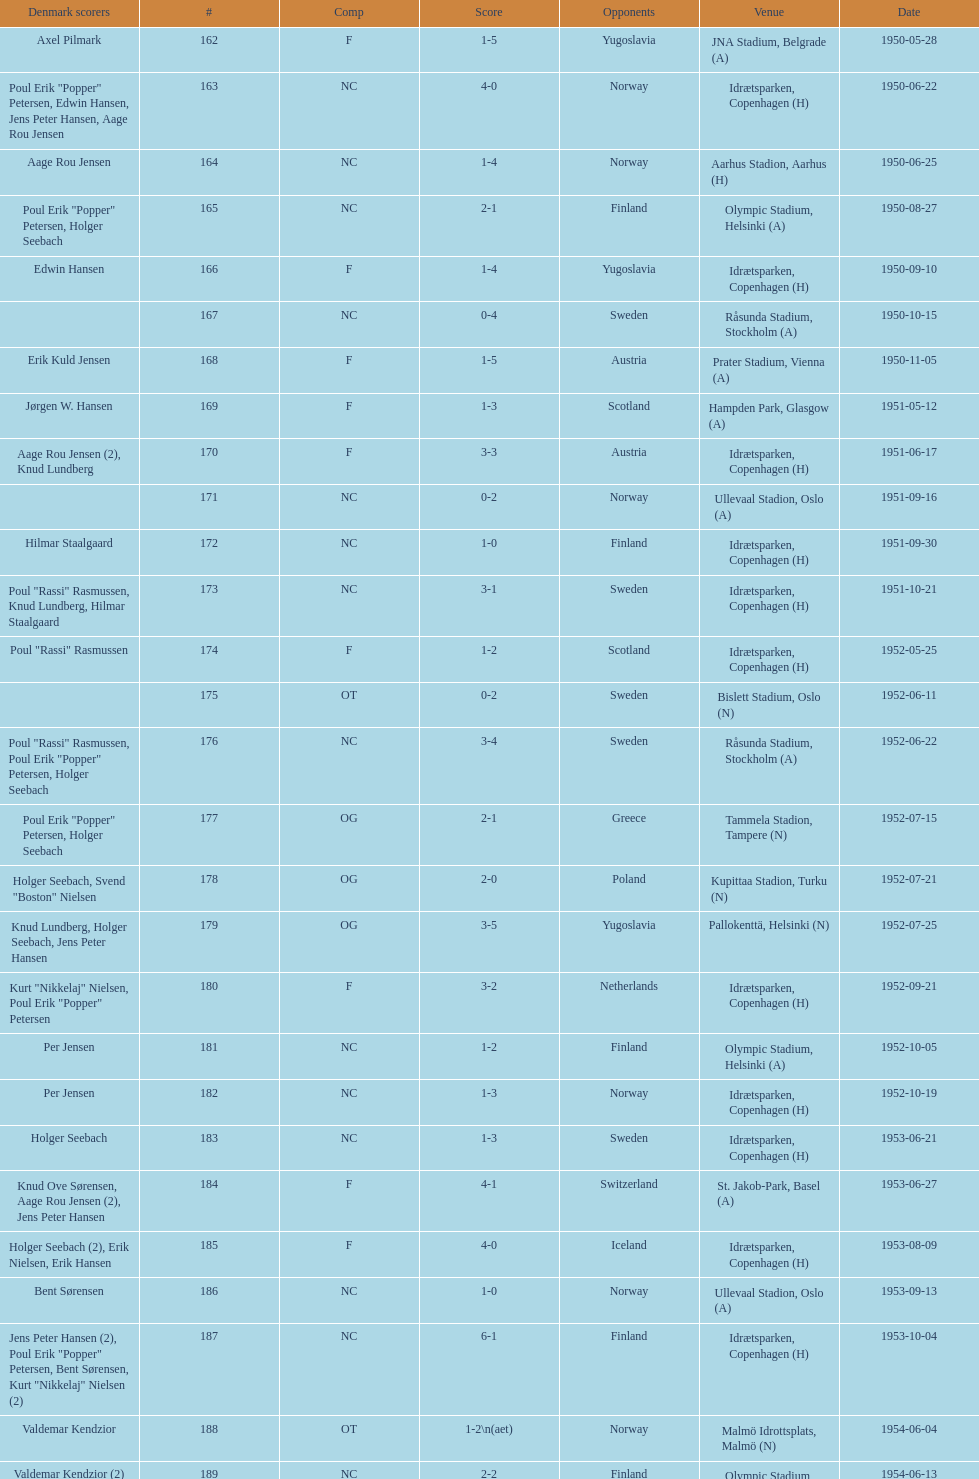When was the last time the team went 0-6? 1959-06-21. 